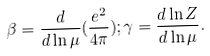Convert formula to latex. <formula><loc_0><loc_0><loc_500><loc_500>\beta = \frac { d } { d \ln \mu } ( \frac { e ^ { 2 } } { 4 \pi } ) ; \gamma = \frac { d \ln Z } { d \ln \mu } .</formula> 